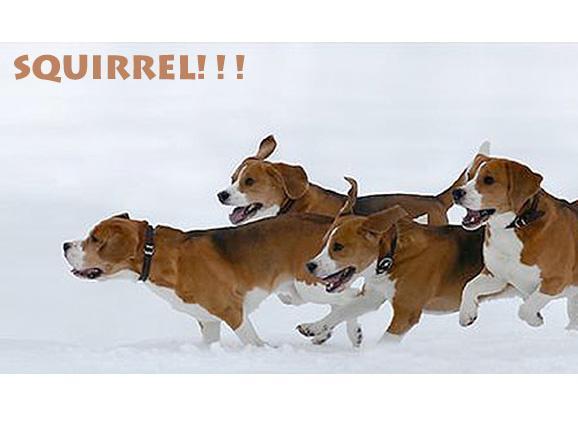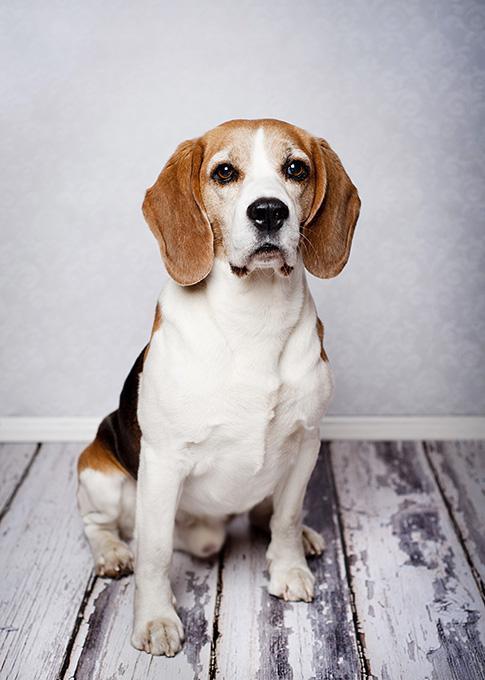The first image is the image on the left, the second image is the image on the right. Evaluate the accuracy of this statement regarding the images: "In one of the images there is a beagle in the sitting position.". Is it true? Answer yes or no. Yes. The first image is the image on the left, the second image is the image on the right. Given the left and right images, does the statement "At least one of the puppies is real and is sitting down." hold true? Answer yes or no. Yes. 